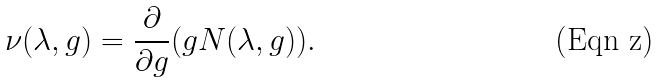<formula> <loc_0><loc_0><loc_500><loc_500>\nu ( \lambda , g ) = \frac { \partial } { \partial g } ( g N ( \lambda , g ) ) .</formula> 